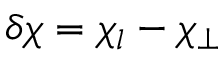Convert formula to latex. <formula><loc_0><loc_0><loc_500><loc_500>\delta \chi = \chi _ { l } - \chi _ { \perp }</formula> 